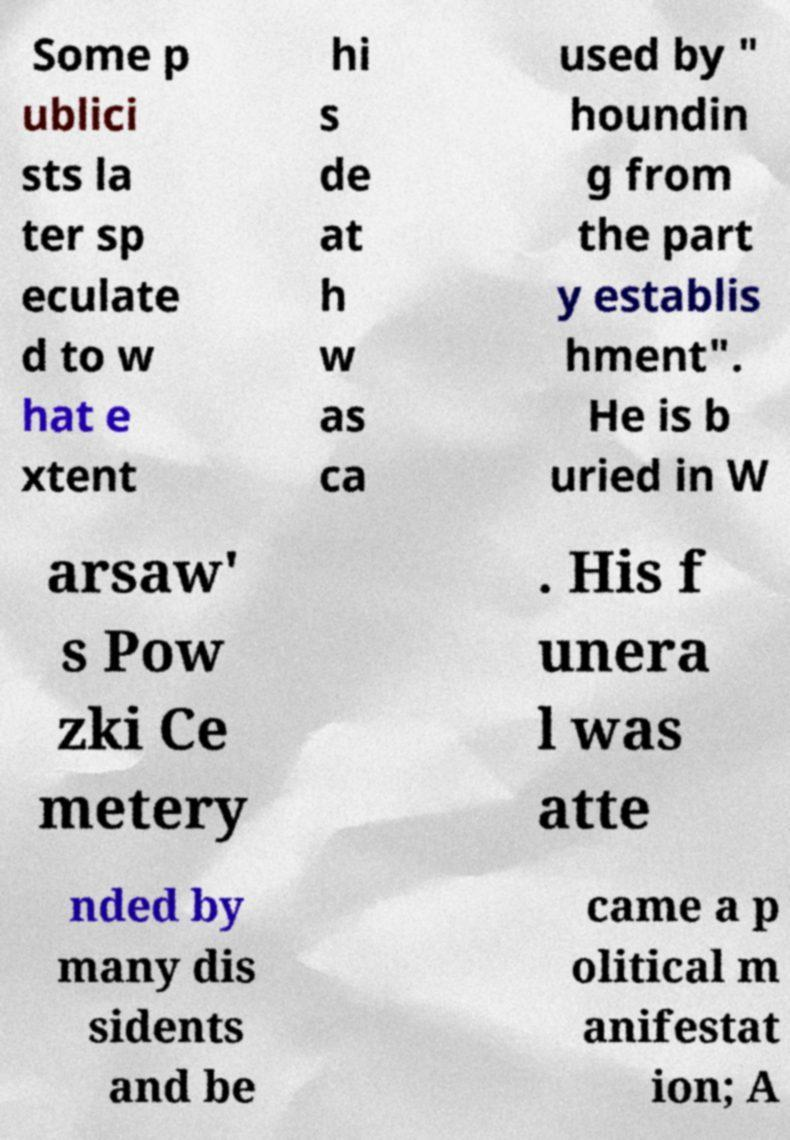What messages or text are displayed in this image? I need them in a readable, typed format. Some p ublici sts la ter sp eculate d to w hat e xtent hi s de at h w as ca used by " houndin g from the part y establis hment". He is b uried in W arsaw' s Pow zki Ce metery . His f unera l was atte nded by many dis sidents and be came a p olitical m anifestat ion; A 